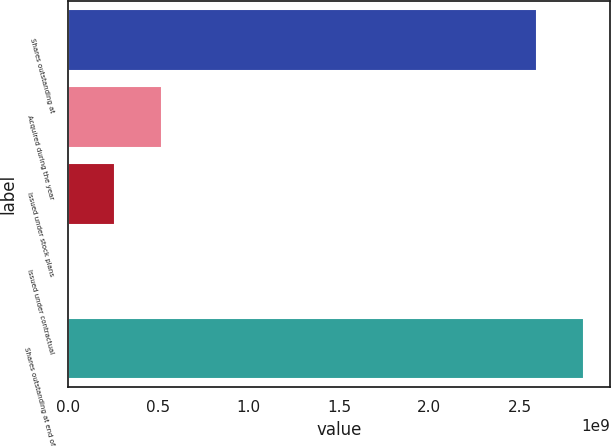Convert chart to OTSL. <chart><loc_0><loc_0><loc_500><loc_500><bar_chart><fcel>Shares outstanding at<fcel>Acquired during the year<fcel>Issued under stock plans<fcel>Issued under contractual<fcel>Shares outstanding at end of<nl><fcel>2.59642e+09<fcel>5.19519e+08<fcel>2.59878e+08<fcel>236870<fcel>2.85606e+09<nl></chart> 